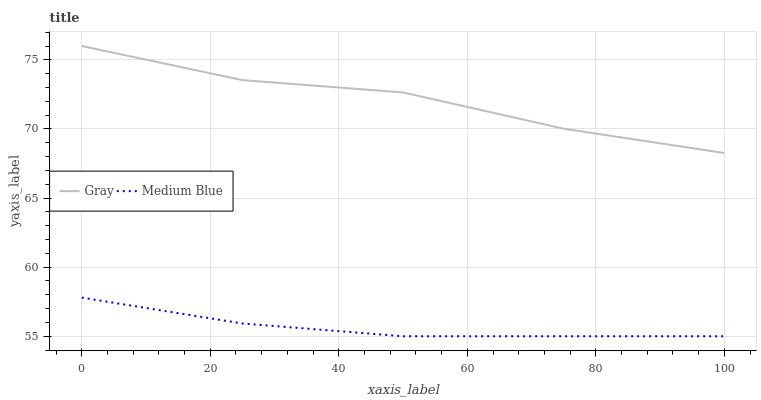Does Medium Blue have the minimum area under the curve?
Answer yes or no. Yes. Does Gray have the maximum area under the curve?
Answer yes or no. Yes. Does Medium Blue have the maximum area under the curve?
Answer yes or no. No. Is Medium Blue the smoothest?
Answer yes or no. Yes. Is Gray the roughest?
Answer yes or no. Yes. Is Medium Blue the roughest?
Answer yes or no. No. Does Medium Blue have the lowest value?
Answer yes or no. Yes. Does Gray have the highest value?
Answer yes or no. Yes. Does Medium Blue have the highest value?
Answer yes or no. No. Is Medium Blue less than Gray?
Answer yes or no. Yes. Is Gray greater than Medium Blue?
Answer yes or no. Yes. Does Medium Blue intersect Gray?
Answer yes or no. No. 